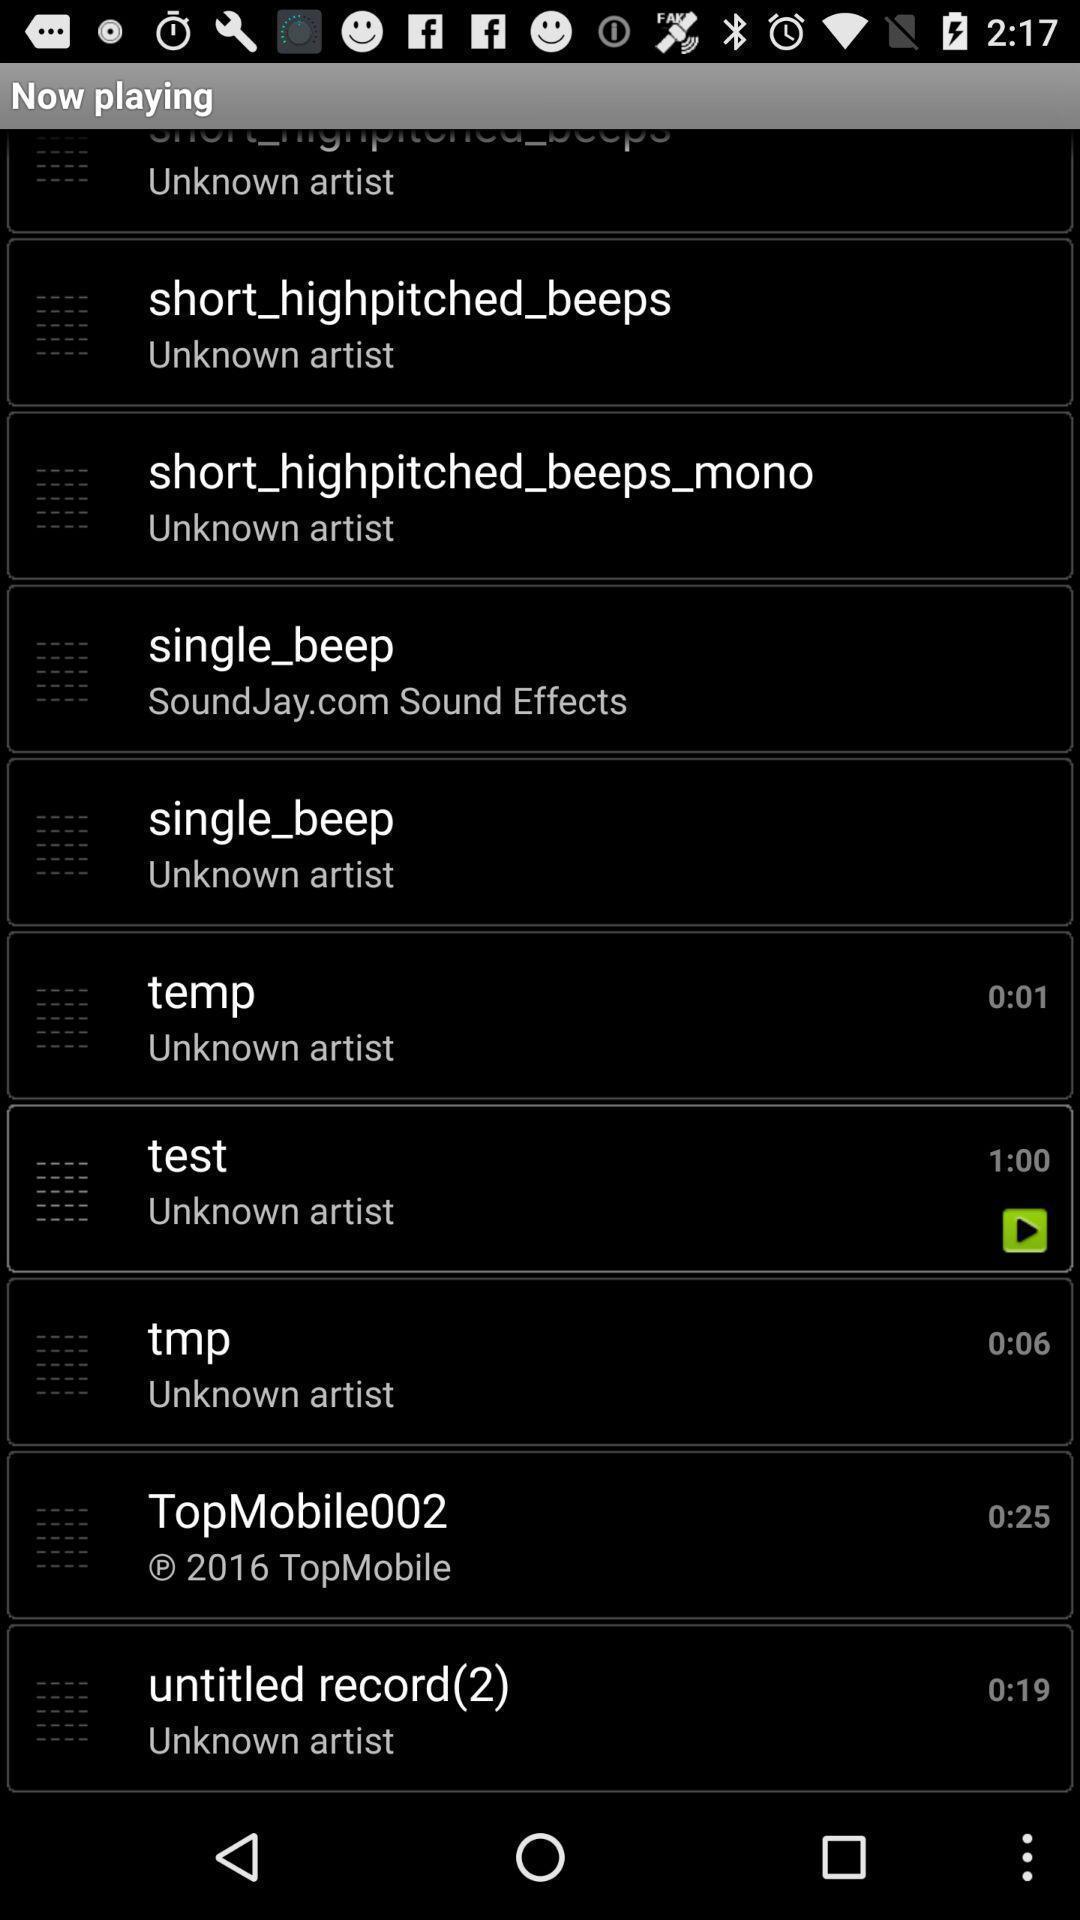Tell me about the visual elements in this screen capture. Page showing list of tunes to play. 